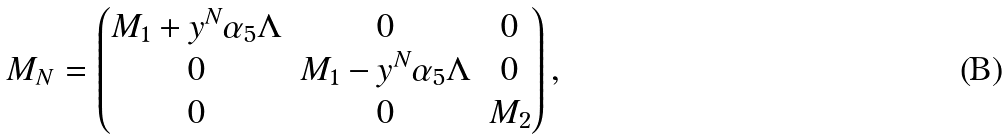<formula> <loc_0><loc_0><loc_500><loc_500>M _ { N } = \begin{pmatrix} M _ { 1 } + y ^ { N } \alpha _ { 5 } \Lambda & 0 & 0 \\ 0 & M _ { 1 } - y ^ { N } \alpha _ { 5 } \Lambda & 0 \\ 0 & 0 & M _ { 2 } \end{pmatrix} ,</formula> 